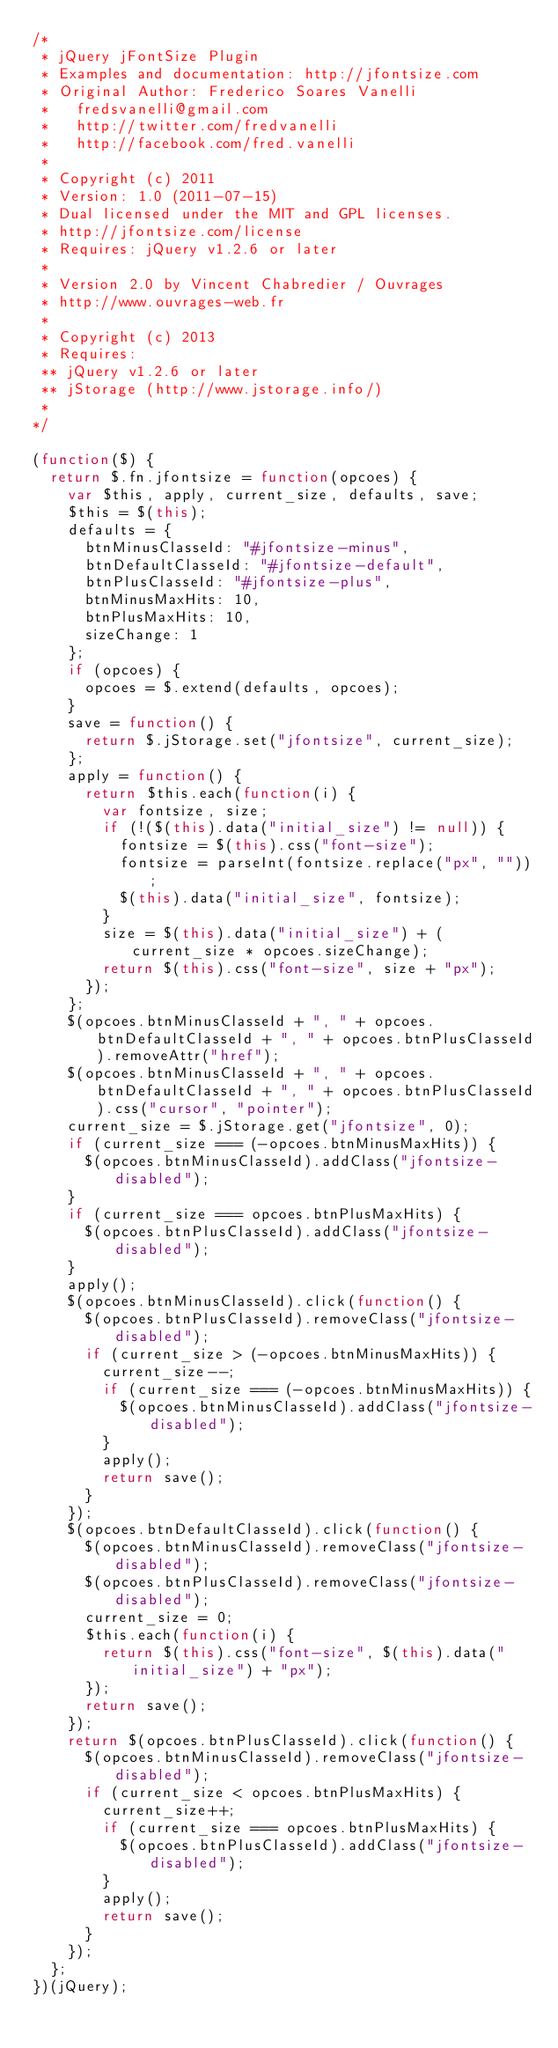Convert code to text. <code><loc_0><loc_0><loc_500><loc_500><_JavaScript_>/*
 * jQuery jFontSize Plugin
 * Examples and documentation: http://jfontsize.com
 * Original Author: Frederico Soares Vanelli
 *   fredsvanelli@gmail.com
 *   http://twitter.com/fredvanelli
 *   http://facebook.com/fred.vanelli
 *
 * Copyright (c) 2011
 * Version: 1.0 (2011-07-15)
 * Dual licensed under the MIT and GPL licenses.
 * http://jfontsize.com/license
 * Requires: jQuery v1.2.6 or later
 * 
 * Version 2.0 by Vincent Chabredier / Ouvrages
 * http://www.ouvrages-web.fr
 *
 * Copyright (c) 2013
 * Requires: 
 ** jQuery v1.2.6 or later
 ** jStorage (http://www.jstorage.info/)
 * 
*/

(function($) {
  return $.fn.jfontsize = function(opcoes) {
    var $this, apply, current_size, defaults, save;
    $this = $(this);
    defaults = {
      btnMinusClasseId: "#jfontsize-minus",
      btnDefaultClasseId: "#jfontsize-default",
      btnPlusClasseId: "#jfontsize-plus",
      btnMinusMaxHits: 10,
      btnPlusMaxHits: 10,
      sizeChange: 1
    };
    if (opcoes) {
      opcoes = $.extend(defaults, opcoes);
    }
    save = function() {
      return $.jStorage.set("jfontsize", current_size);
    };
    apply = function() {
      return $this.each(function(i) {
        var fontsize, size;
        if (!($(this).data("initial_size") != null)) {
          fontsize = $(this).css("font-size");
          fontsize = parseInt(fontsize.replace("px", ""));
          $(this).data("initial_size", fontsize);
        }
        size = $(this).data("initial_size") + (current_size * opcoes.sizeChange);
        return $(this).css("font-size", size + "px");
      });
    };
    $(opcoes.btnMinusClasseId + ", " + opcoes.btnDefaultClasseId + ", " + opcoes.btnPlusClasseId).removeAttr("href");
    $(opcoes.btnMinusClasseId + ", " + opcoes.btnDefaultClasseId + ", " + opcoes.btnPlusClasseId).css("cursor", "pointer");
    current_size = $.jStorage.get("jfontsize", 0);
    if (current_size === (-opcoes.btnMinusMaxHits)) {
      $(opcoes.btnMinusClasseId).addClass("jfontsize-disabled");
    }
    if (current_size === opcoes.btnPlusMaxHits) {
      $(opcoes.btnPlusClasseId).addClass("jfontsize-disabled");
    }
    apply();
    $(opcoes.btnMinusClasseId).click(function() {
      $(opcoes.btnPlusClasseId).removeClass("jfontsize-disabled");
      if (current_size > (-opcoes.btnMinusMaxHits)) {
        current_size--;
        if (current_size === (-opcoes.btnMinusMaxHits)) {
          $(opcoes.btnMinusClasseId).addClass("jfontsize-disabled");
        }
        apply();
        return save();
      }
    });
    $(opcoes.btnDefaultClasseId).click(function() {
      $(opcoes.btnMinusClasseId).removeClass("jfontsize-disabled");
      $(opcoes.btnPlusClasseId).removeClass("jfontsize-disabled");
      current_size = 0;
      $this.each(function(i) {
        return $(this).css("font-size", $(this).data("initial_size") + "px");
      });
      return save();
    });
    return $(opcoes.btnPlusClasseId).click(function() {
      $(opcoes.btnMinusClasseId).removeClass("jfontsize-disabled");
      if (current_size < opcoes.btnPlusMaxHits) {
        current_size++;
        if (current_size === opcoes.btnPlusMaxHits) {
          $(opcoes.btnPlusClasseId).addClass("jfontsize-disabled");
        }
        apply();
        return save();
      }
    });
  };
})(jQuery);</code> 